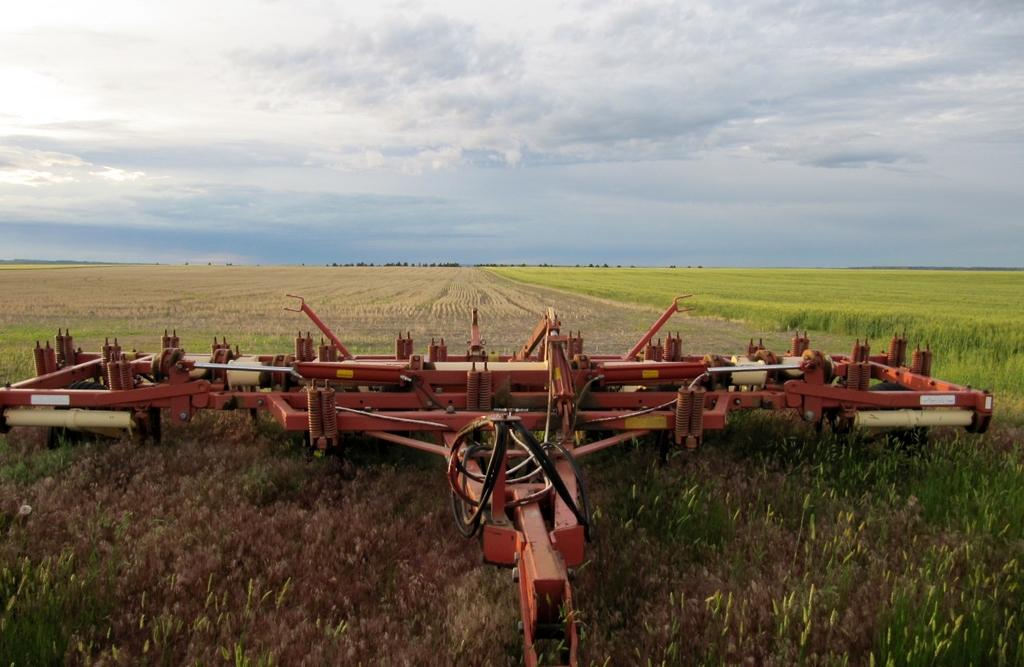What is the main subject of the image? The main subject of the image is a field cultivator. Where is the field cultivator located? The field cultivator is in a field. What can be seen in the background of the image? There are trees at the back of the image. What is visible at the top of the image? The sky is visible at the top of the image. How many nails are used to hold the basket in the image? There is no basket or nails present in the image. What type of force is being applied to the field cultivator in the image? The image does not show any force being applied to the field cultivator; it is stationary in the field. 